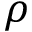<formula> <loc_0><loc_0><loc_500><loc_500>\rho</formula> 